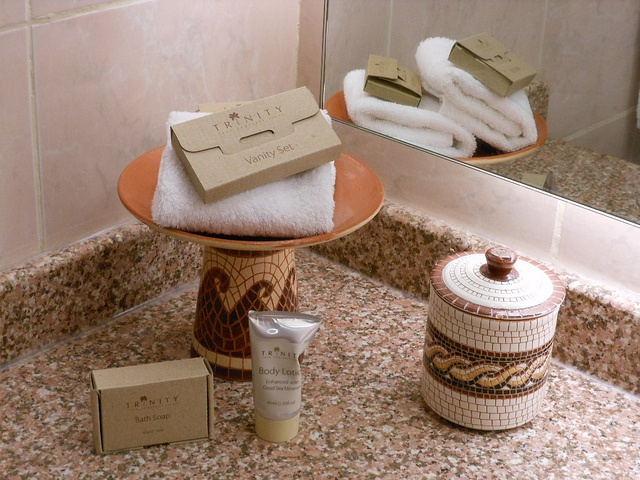Describe the objects in this image and their specific colors. I can see various objects in this image with different colors. 